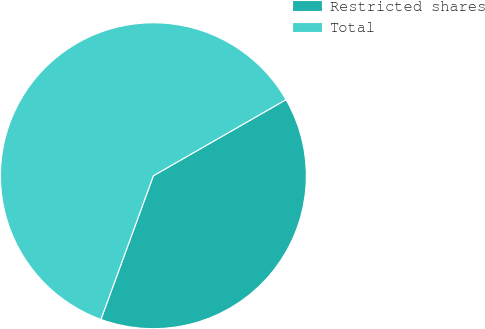Convert chart. <chart><loc_0><loc_0><loc_500><loc_500><pie_chart><fcel>Restricted shares<fcel>Total<nl><fcel>38.86%<fcel>61.14%<nl></chart> 